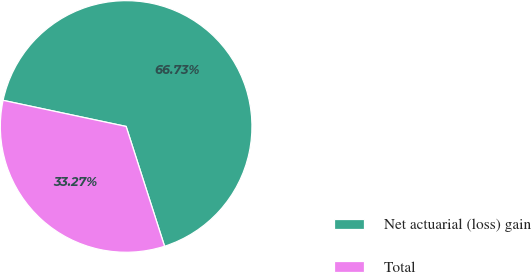Convert chart. <chart><loc_0><loc_0><loc_500><loc_500><pie_chart><fcel>Net actuarial (loss) gain<fcel>Total<nl><fcel>66.73%<fcel>33.27%<nl></chart> 